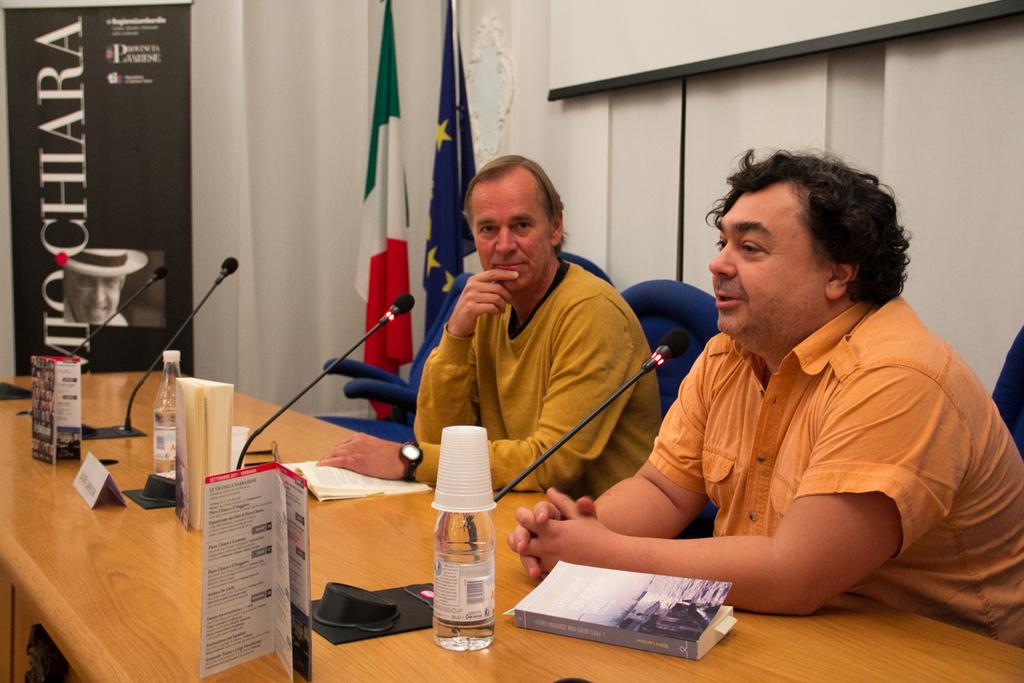How many men are in the image? There are two men in the image. What are the men doing in the image? The men are sitting on chairs in front of a table. What is one of the men doing with a microphone? One of the men is talking on a microphone. What objects can be seen on the table? There is a book, a bottle, and cups on the table. What can be seen on the wall in the image? There are two flags on the wall. How many dolls are sitting on the chairs with the men in the image? There are no dolls present in the image; only the two men are sitting on the chairs. 